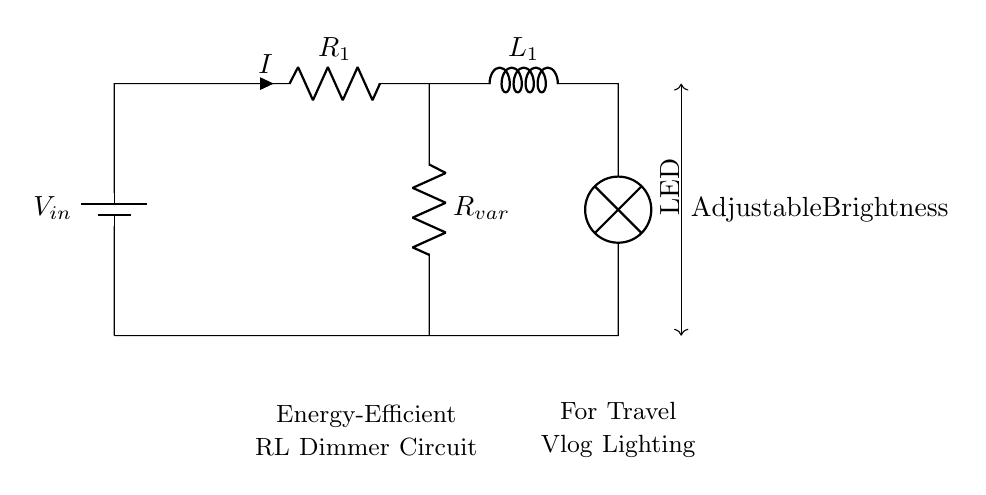What is the input voltage of this circuit? The input voltage, labeled \( V_{in} \), represents the power supply connected at the top of the circuit and is typically the source voltage used for the circuit operation.
Answer: \( V_{in} \) What component limits the current in this circuit? The resistor \( R_1 \) limits the current flowing through the LED. In series with the inductor \( L_1 \), it controls the intensity of the light emitted by the LED.
Answer: \( R_1 \) Which component is responsible for adjusting brightness? The variable resistor \( R_{var} \) allows adjustment of the resistance in the circuit, hence controlling the current and ultimately the brightness of the LED.
Answer: \( R_{var} \) What type of circuit is this identified as? The presence of both a resistor \( R \) and an inductor \( L \) connected in series indicates that this is an RL circuit, which is known for its ability to reduce flicker in lighting applications.
Answer: RL circuit How does the inductor affect the circuit's performance? The inductor \( L_1 \) stores energy in a magnetic field when current flows through it, which helps in smoothing out the current fluctuations created when dimming the LED, therefore providing stable lighting.
Answer: Smoothes current 